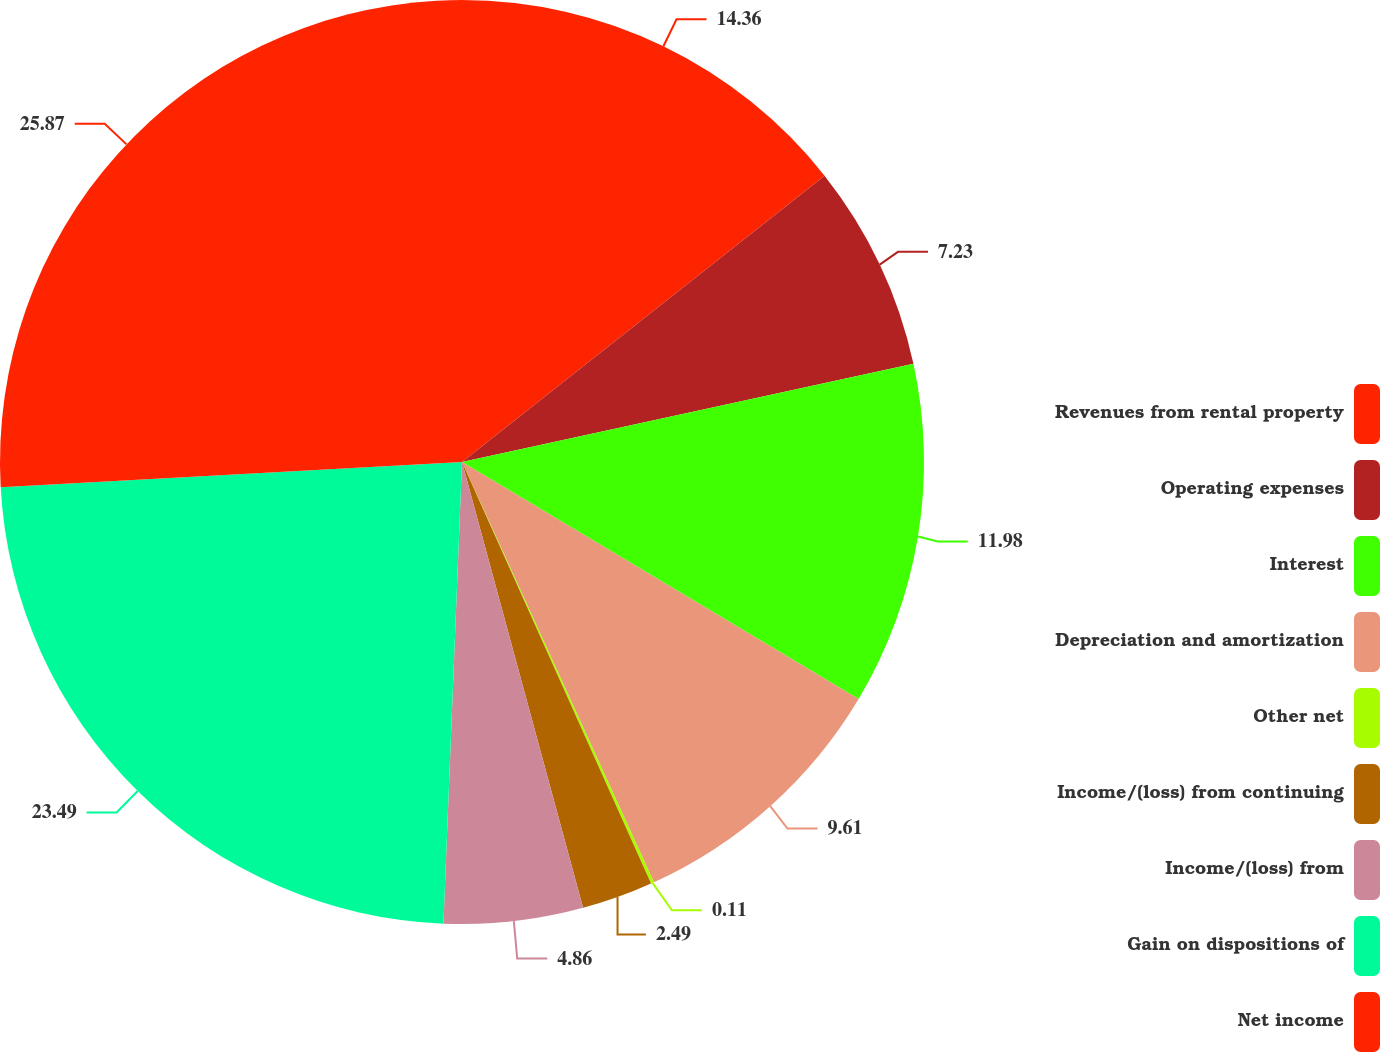<chart> <loc_0><loc_0><loc_500><loc_500><pie_chart><fcel>Revenues from rental property<fcel>Operating expenses<fcel>Interest<fcel>Depreciation and amortization<fcel>Other net<fcel>Income/(loss) from continuing<fcel>Income/(loss) from<fcel>Gain on dispositions of<fcel>Net income<nl><fcel>14.36%<fcel>7.23%<fcel>11.98%<fcel>9.61%<fcel>0.11%<fcel>2.49%<fcel>4.86%<fcel>23.49%<fcel>25.87%<nl></chart> 